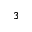<formula> <loc_0><loc_0><loc_500><loc_500>3</formula> 